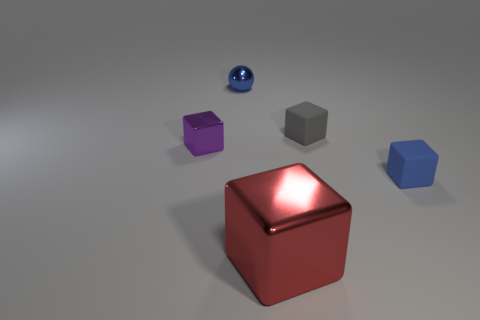Subtract 2 cubes. How many cubes are left? 2 Subtract all small metal blocks. How many blocks are left? 3 Subtract all purple blocks. How many blocks are left? 3 Add 2 blue metal things. How many objects exist? 7 Subtract all spheres. How many objects are left? 4 Subtract all yellow blocks. Subtract all red balls. How many blocks are left? 4 Subtract all gray things. Subtract all large objects. How many objects are left? 3 Add 4 tiny purple shiny objects. How many tiny purple shiny objects are left? 5 Add 4 big cyan cubes. How many big cyan cubes exist? 4 Subtract 0 green cubes. How many objects are left? 5 